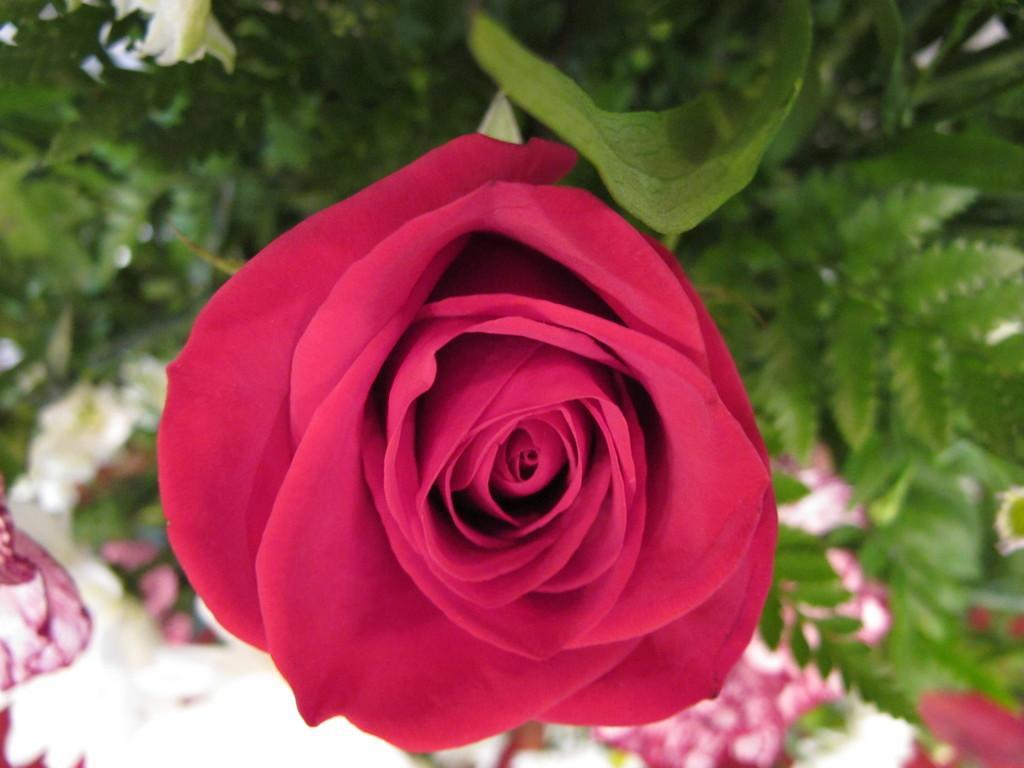Describe this image in one or two sentences. In this image there is a pinkish red color rose with a leaf,and at the background there are leaves. 